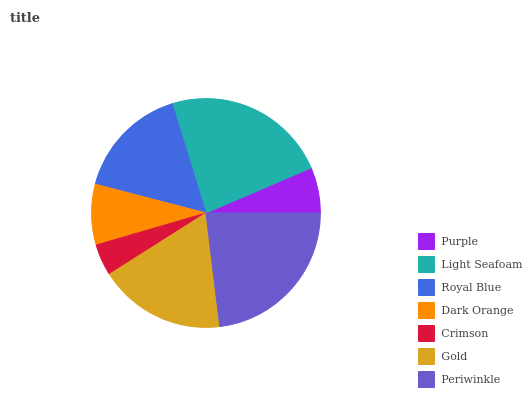Is Crimson the minimum?
Answer yes or no. Yes. Is Light Seafoam the maximum?
Answer yes or no. Yes. Is Royal Blue the minimum?
Answer yes or no. No. Is Royal Blue the maximum?
Answer yes or no. No. Is Light Seafoam greater than Royal Blue?
Answer yes or no. Yes. Is Royal Blue less than Light Seafoam?
Answer yes or no. Yes. Is Royal Blue greater than Light Seafoam?
Answer yes or no. No. Is Light Seafoam less than Royal Blue?
Answer yes or no. No. Is Royal Blue the high median?
Answer yes or no. Yes. Is Royal Blue the low median?
Answer yes or no. Yes. Is Gold the high median?
Answer yes or no. No. Is Crimson the low median?
Answer yes or no. No. 